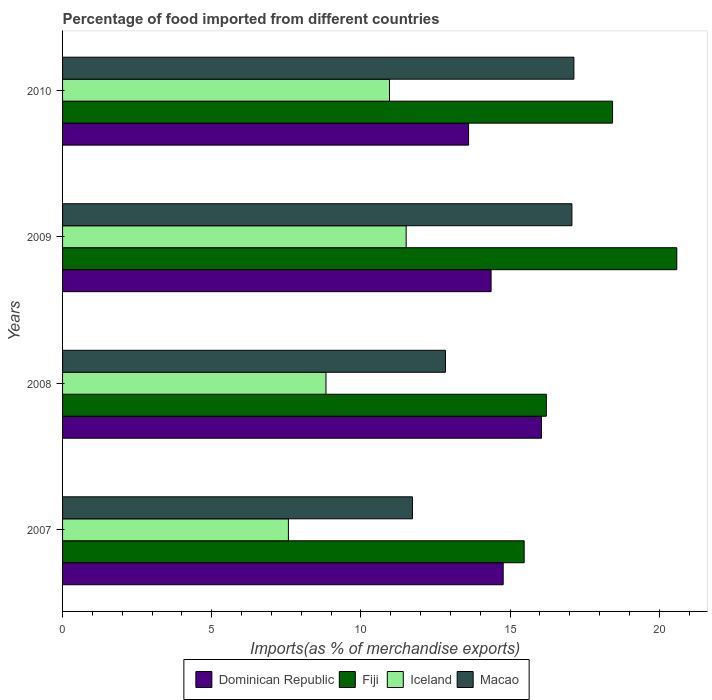Are the number of bars per tick equal to the number of legend labels?
Provide a short and direct response. Yes. Are the number of bars on each tick of the Y-axis equal?
Provide a succinct answer. Yes. How many bars are there on the 1st tick from the bottom?
Keep it short and to the point. 4. What is the label of the 3rd group of bars from the top?
Your answer should be compact. 2008. In how many cases, is the number of bars for a given year not equal to the number of legend labels?
Ensure brevity in your answer.  0. What is the percentage of imports to different countries in Macao in 2009?
Offer a terse response. 17.07. Across all years, what is the maximum percentage of imports to different countries in Fiji?
Offer a terse response. 20.59. Across all years, what is the minimum percentage of imports to different countries in Dominican Republic?
Offer a very short reply. 13.61. In which year was the percentage of imports to different countries in Dominican Republic minimum?
Keep it short and to the point. 2010. What is the total percentage of imports to different countries in Macao in the graph?
Keep it short and to the point. 58.77. What is the difference between the percentage of imports to different countries in Dominican Republic in 2009 and that in 2010?
Give a very brief answer. 0.75. What is the difference between the percentage of imports to different countries in Fiji in 2010 and the percentage of imports to different countries in Dominican Republic in 2009?
Offer a very short reply. 4.07. What is the average percentage of imports to different countries in Dominican Republic per year?
Your answer should be very brief. 14.7. In the year 2008, what is the difference between the percentage of imports to different countries in Iceland and percentage of imports to different countries in Dominican Republic?
Offer a very short reply. -7.22. What is the ratio of the percentage of imports to different countries in Macao in 2008 to that in 2009?
Your response must be concise. 0.75. Is the difference between the percentage of imports to different countries in Iceland in 2007 and 2008 greater than the difference between the percentage of imports to different countries in Dominican Republic in 2007 and 2008?
Provide a short and direct response. Yes. What is the difference between the highest and the second highest percentage of imports to different countries in Macao?
Give a very brief answer. 0.07. What is the difference between the highest and the lowest percentage of imports to different countries in Macao?
Your answer should be compact. 5.41. In how many years, is the percentage of imports to different countries in Macao greater than the average percentage of imports to different countries in Macao taken over all years?
Keep it short and to the point. 2. Is the sum of the percentage of imports to different countries in Dominican Republic in 2007 and 2008 greater than the maximum percentage of imports to different countries in Iceland across all years?
Make the answer very short. Yes. Is it the case that in every year, the sum of the percentage of imports to different countries in Macao and percentage of imports to different countries in Fiji is greater than the sum of percentage of imports to different countries in Dominican Republic and percentage of imports to different countries in Iceland?
Offer a very short reply. No. What does the 3rd bar from the top in 2010 represents?
Make the answer very short. Fiji. What does the 1st bar from the bottom in 2009 represents?
Your answer should be compact. Dominican Republic. Is it the case that in every year, the sum of the percentage of imports to different countries in Macao and percentage of imports to different countries in Fiji is greater than the percentage of imports to different countries in Dominican Republic?
Make the answer very short. Yes. How many bars are there?
Make the answer very short. 16. Are all the bars in the graph horizontal?
Give a very brief answer. Yes. How many years are there in the graph?
Your answer should be very brief. 4. What is the difference between two consecutive major ticks on the X-axis?
Give a very brief answer. 5. Are the values on the major ticks of X-axis written in scientific E-notation?
Your answer should be very brief. No. Does the graph contain grids?
Offer a terse response. No. Where does the legend appear in the graph?
Ensure brevity in your answer.  Bottom center. How are the legend labels stacked?
Provide a short and direct response. Horizontal. What is the title of the graph?
Your answer should be very brief. Percentage of food imported from different countries. What is the label or title of the X-axis?
Your response must be concise. Imports(as % of merchandise exports). What is the Imports(as % of merchandise exports) in Dominican Republic in 2007?
Provide a succinct answer. 14.77. What is the Imports(as % of merchandise exports) of Fiji in 2007?
Your answer should be very brief. 15.47. What is the Imports(as % of merchandise exports) of Iceland in 2007?
Offer a terse response. 7.57. What is the Imports(as % of merchandise exports) of Macao in 2007?
Your response must be concise. 11.73. What is the Imports(as % of merchandise exports) of Dominican Republic in 2008?
Offer a terse response. 16.05. What is the Imports(as % of merchandise exports) in Fiji in 2008?
Keep it short and to the point. 16.22. What is the Imports(as % of merchandise exports) of Iceland in 2008?
Your answer should be compact. 8.83. What is the Imports(as % of merchandise exports) in Macao in 2008?
Offer a very short reply. 12.83. What is the Imports(as % of merchandise exports) of Dominican Republic in 2009?
Your response must be concise. 14.36. What is the Imports(as % of merchandise exports) of Fiji in 2009?
Make the answer very short. 20.59. What is the Imports(as % of merchandise exports) of Iceland in 2009?
Give a very brief answer. 11.52. What is the Imports(as % of merchandise exports) in Macao in 2009?
Provide a succinct answer. 17.07. What is the Imports(as % of merchandise exports) of Dominican Republic in 2010?
Offer a very short reply. 13.61. What is the Imports(as % of merchandise exports) in Fiji in 2010?
Provide a succinct answer. 18.43. What is the Imports(as % of merchandise exports) in Iceland in 2010?
Offer a very short reply. 10.96. What is the Imports(as % of merchandise exports) in Macao in 2010?
Make the answer very short. 17.14. Across all years, what is the maximum Imports(as % of merchandise exports) in Dominican Republic?
Your response must be concise. 16.05. Across all years, what is the maximum Imports(as % of merchandise exports) in Fiji?
Keep it short and to the point. 20.59. Across all years, what is the maximum Imports(as % of merchandise exports) in Iceland?
Your answer should be very brief. 11.52. Across all years, what is the maximum Imports(as % of merchandise exports) of Macao?
Ensure brevity in your answer.  17.14. Across all years, what is the minimum Imports(as % of merchandise exports) in Dominican Republic?
Your answer should be very brief. 13.61. Across all years, what is the minimum Imports(as % of merchandise exports) of Fiji?
Provide a short and direct response. 15.47. Across all years, what is the minimum Imports(as % of merchandise exports) of Iceland?
Offer a terse response. 7.57. Across all years, what is the minimum Imports(as % of merchandise exports) of Macao?
Ensure brevity in your answer.  11.73. What is the total Imports(as % of merchandise exports) of Dominican Republic in the graph?
Provide a succinct answer. 58.8. What is the total Imports(as % of merchandise exports) of Fiji in the graph?
Ensure brevity in your answer.  70.71. What is the total Imports(as % of merchandise exports) in Iceland in the graph?
Provide a succinct answer. 38.88. What is the total Imports(as % of merchandise exports) of Macao in the graph?
Give a very brief answer. 58.77. What is the difference between the Imports(as % of merchandise exports) of Dominican Republic in 2007 and that in 2008?
Provide a succinct answer. -1.28. What is the difference between the Imports(as % of merchandise exports) of Fiji in 2007 and that in 2008?
Keep it short and to the point. -0.74. What is the difference between the Imports(as % of merchandise exports) in Iceland in 2007 and that in 2008?
Make the answer very short. -1.26. What is the difference between the Imports(as % of merchandise exports) of Macao in 2007 and that in 2008?
Offer a very short reply. -1.11. What is the difference between the Imports(as % of merchandise exports) in Dominican Republic in 2007 and that in 2009?
Your answer should be compact. 0.41. What is the difference between the Imports(as % of merchandise exports) of Fiji in 2007 and that in 2009?
Offer a terse response. -5.12. What is the difference between the Imports(as % of merchandise exports) of Iceland in 2007 and that in 2009?
Offer a very short reply. -3.95. What is the difference between the Imports(as % of merchandise exports) of Macao in 2007 and that in 2009?
Offer a terse response. -5.35. What is the difference between the Imports(as % of merchandise exports) of Dominican Republic in 2007 and that in 2010?
Your response must be concise. 1.16. What is the difference between the Imports(as % of merchandise exports) of Fiji in 2007 and that in 2010?
Keep it short and to the point. -2.96. What is the difference between the Imports(as % of merchandise exports) of Iceland in 2007 and that in 2010?
Keep it short and to the point. -3.39. What is the difference between the Imports(as % of merchandise exports) of Macao in 2007 and that in 2010?
Your answer should be compact. -5.41. What is the difference between the Imports(as % of merchandise exports) in Dominican Republic in 2008 and that in 2009?
Your answer should be compact. 1.69. What is the difference between the Imports(as % of merchandise exports) in Fiji in 2008 and that in 2009?
Your answer should be compact. -4.37. What is the difference between the Imports(as % of merchandise exports) in Iceland in 2008 and that in 2009?
Keep it short and to the point. -2.69. What is the difference between the Imports(as % of merchandise exports) in Macao in 2008 and that in 2009?
Your response must be concise. -4.24. What is the difference between the Imports(as % of merchandise exports) of Dominican Republic in 2008 and that in 2010?
Your response must be concise. 2.44. What is the difference between the Imports(as % of merchandise exports) in Fiji in 2008 and that in 2010?
Your response must be concise. -2.22. What is the difference between the Imports(as % of merchandise exports) of Iceland in 2008 and that in 2010?
Ensure brevity in your answer.  -2.13. What is the difference between the Imports(as % of merchandise exports) in Macao in 2008 and that in 2010?
Make the answer very short. -4.31. What is the difference between the Imports(as % of merchandise exports) of Dominican Republic in 2009 and that in 2010?
Ensure brevity in your answer.  0.75. What is the difference between the Imports(as % of merchandise exports) in Fiji in 2009 and that in 2010?
Provide a succinct answer. 2.15. What is the difference between the Imports(as % of merchandise exports) in Iceland in 2009 and that in 2010?
Make the answer very short. 0.56. What is the difference between the Imports(as % of merchandise exports) in Macao in 2009 and that in 2010?
Ensure brevity in your answer.  -0.07. What is the difference between the Imports(as % of merchandise exports) of Dominican Republic in 2007 and the Imports(as % of merchandise exports) of Fiji in 2008?
Offer a terse response. -1.45. What is the difference between the Imports(as % of merchandise exports) of Dominican Republic in 2007 and the Imports(as % of merchandise exports) of Iceland in 2008?
Your answer should be very brief. 5.94. What is the difference between the Imports(as % of merchandise exports) of Dominican Republic in 2007 and the Imports(as % of merchandise exports) of Macao in 2008?
Give a very brief answer. 1.94. What is the difference between the Imports(as % of merchandise exports) in Fiji in 2007 and the Imports(as % of merchandise exports) in Iceland in 2008?
Provide a succinct answer. 6.64. What is the difference between the Imports(as % of merchandise exports) in Fiji in 2007 and the Imports(as % of merchandise exports) in Macao in 2008?
Offer a very short reply. 2.64. What is the difference between the Imports(as % of merchandise exports) of Iceland in 2007 and the Imports(as % of merchandise exports) of Macao in 2008?
Your answer should be compact. -5.26. What is the difference between the Imports(as % of merchandise exports) of Dominican Republic in 2007 and the Imports(as % of merchandise exports) of Fiji in 2009?
Provide a short and direct response. -5.82. What is the difference between the Imports(as % of merchandise exports) in Dominican Republic in 2007 and the Imports(as % of merchandise exports) in Iceland in 2009?
Keep it short and to the point. 3.25. What is the difference between the Imports(as % of merchandise exports) of Dominican Republic in 2007 and the Imports(as % of merchandise exports) of Macao in 2009?
Your answer should be very brief. -2.3. What is the difference between the Imports(as % of merchandise exports) in Fiji in 2007 and the Imports(as % of merchandise exports) in Iceland in 2009?
Offer a very short reply. 3.96. What is the difference between the Imports(as % of merchandise exports) of Fiji in 2007 and the Imports(as % of merchandise exports) of Macao in 2009?
Provide a succinct answer. -1.6. What is the difference between the Imports(as % of merchandise exports) in Iceland in 2007 and the Imports(as % of merchandise exports) in Macao in 2009?
Keep it short and to the point. -9.5. What is the difference between the Imports(as % of merchandise exports) in Dominican Republic in 2007 and the Imports(as % of merchandise exports) in Fiji in 2010?
Give a very brief answer. -3.67. What is the difference between the Imports(as % of merchandise exports) in Dominican Republic in 2007 and the Imports(as % of merchandise exports) in Iceland in 2010?
Ensure brevity in your answer.  3.81. What is the difference between the Imports(as % of merchandise exports) of Dominican Republic in 2007 and the Imports(as % of merchandise exports) of Macao in 2010?
Your response must be concise. -2.37. What is the difference between the Imports(as % of merchandise exports) in Fiji in 2007 and the Imports(as % of merchandise exports) in Iceland in 2010?
Make the answer very short. 4.51. What is the difference between the Imports(as % of merchandise exports) in Fiji in 2007 and the Imports(as % of merchandise exports) in Macao in 2010?
Your response must be concise. -1.67. What is the difference between the Imports(as % of merchandise exports) in Iceland in 2007 and the Imports(as % of merchandise exports) in Macao in 2010?
Offer a very short reply. -9.57. What is the difference between the Imports(as % of merchandise exports) of Dominican Republic in 2008 and the Imports(as % of merchandise exports) of Fiji in 2009?
Provide a succinct answer. -4.53. What is the difference between the Imports(as % of merchandise exports) in Dominican Republic in 2008 and the Imports(as % of merchandise exports) in Iceland in 2009?
Your answer should be very brief. 4.54. What is the difference between the Imports(as % of merchandise exports) in Dominican Republic in 2008 and the Imports(as % of merchandise exports) in Macao in 2009?
Provide a short and direct response. -1.02. What is the difference between the Imports(as % of merchandise exports) of Fiji in 2008 and the Imports(as % of merchandise exports) of Iceland in 2009?
Provide a short and direct response. 4.7. What is the difference between the Imports(as % of merchandise exports) of Fiji in 2008 and the Imports(as % of merchandise exports) of Macao in 2009?
Provide a succinct answer. -0.86. What is the difference between the Imports(as % of merchandise exports) in Iceland in 2008 and the Imports(as % of merchandise exports) in Macao in 2009?
Offer a very short reply. -8.24. What is the difference between the Imports(as % of merchandise exports) of Dominican Republic in 2008 and the Imports(as % of merchandise exports) of Fiji in 2010?
Offer a very short reply. -2.38. What is the difference between the Imports(as % of merchandise exports) in Dominican Republic in 2008 and the Imports(as % of merchandise exports) in Iceland in 2010?
Offer a terse response. 5.09. What is the difference between the Imports(as % of merchandise exports) in Dominican Republic in 2008 and the Imports(as % of merchandise exports) in Macao in 2010?
Your response must be concise. -1.09. What is the difference between the Imports(as % of merchandise exports) of Fiji in 2008 and the Imports(as % of merchandise exports) of Iceland in 2010?
Offer a terse response. 5.26. What is the difference between the Imports(as % of merchandise exports) in Fiji in 2008 and the Imports(as % of merchandise exports) in Macao in 2010?
Your answer should be very brief. -0.92. What is the difference between the Imports(as % of merchandise exports) in Iceland in 2008 and the Imports(as % of merchandise exports) in Macao in 2010?
Offer a terse response. -8.31. What is the difference between the Imports(as % of merchandise exports) in Dominican Republic in 2009 and the Imports(as % of merchandise exports) in Fiji in 2010?
Ensure brevity in your answer.  -4.07. What is the difference between the Imports(as % of merchandise exports) in Dominican Republic in 2009 and the Imports(as % of merchandise exports) in Iceland in 2010?
Provide a succinct answer. 3.4. What is the difference between the Imports(as % of merchandise exports) in Dominican Republic in 2009 and the Imports(as % of merchandise exports) in Macao in 2010?
Make the answer very short. -2.78. What is the difference between the Imports(as % of merchandise exports) of Fiji in 2009 and the Imports(as % of merchandise exports) of Iceland in 2010?
Your answer should be compact. 9.63. What is the difference between the Imports(as % of merchandise exports) of Fiji in 2009 and the Imports(as % of merchandise exports) of Macao in 2010?
Provide a succinct answer. 3.45. What is the difference between the Imports(as % of merchandise exports) of Iceland in 2009 and the Imports(as % of merchandise exports) of Macao in 2010?
Offer a terse response. -5.62. What is the average Imports(as % of merchandise exports) of Dominican Republic per year?
Ensure brevity in your answer.  14.7. What is the average Imports(as % of merchandise exports) in Fiji per year?
Provide a short and direct response. 17.68. What is the average Imports(as % of merchandise exports) in Iceland per year?
Your answer should be very brief. 9.72. What is the average Imports(as % of merchandise exports) in Macao per year?
Ensure brevity in your answer.  14.69. In the year 2007, what is the difference between the Imports(as % of merchandise exports) in Dominican Republic and Imports(as % of merchandise exports) in Fiji?
Keep it short and to the point. -0.7. In the year 2007, what is the difference between the Imports(as % of merchandise exports) of Dominican Republic and Imports(as % of merchandise exports) of Iceland?
Your answer should be very brief. 7.2. In the year 2007, what is the difference between the Imports(as % of merchandise exports) in Dominican Republic and Imports(as % of merchandise exports) in Macao?
Make the answer very short. 3.04. In the year 2007, what is the difference between the Imports(as % of merchandise exports) of Fiji and Imports(as % of merchandise exports) of Iceland?
Your answer should be compact. 7.9. In the year 2007, what is the difference between the Imports(as % of merchandise exports) in Fiji and Imports(as % of merchandise exports) in Macao?
Make the answer very short. 3.75. In the year 2007, what is the difference between the Imports(as % of merchandise exports) in Iceland and Imports(as % of merchandise exports) in Macao?
Offer a very short reply. -4.16. In the year 2008, what is the difference between the Imports(as % of merchandise exports) in Dominican Republic and Imports(as % of merchandise exports) in Fiji?
Provide a short and direct response. -0.16. In the year 2008, what is the difference between the Imports(as % of merchandise exports) in Dominican Republic and Imports(as % of merchandise exports) in Iceland?
Keep it short and to the point. 7.22. In the year 2008, what is the difference between the Imports(as % of merchandise exports) of Dominican Republic and Imports(as % of merchandise exports) of Macao?
Ensure brevity in your answer.  3.22. In the year 2008, what is the difference between the Imports(as % of merchandise exports) in Fiji and Imports(as % of merchandise exports) in Iceland?
Provide a short and direct response. 7.39. In the year 2008, what is the difference between the Imports(as % of merchandise exports) in Fiji and Imports(as % of merchandise exports) in Macao?
Provide a succinct answer. 3.38. In the year 2008, what is the difference between the Imports(as % of merchandise exports) in Iceland and Imports(as % of merchandise exports) in Macao?
Provide a succinct answer. -4.01. In the year 2009, what is the difference between the Imports(as % of merchandise exports) of Dominican Republic and Imports(as % of merchandise exports) of Fiji?
Offer a terse response. -6.22. In the year 2009, what is the difference between the Imports(as % of merchandise exports) in Dominican Republic and Imports(as % of merchandise exports) in Iceland?
Give a very brief answer. 2.85. In the year 2009, what is the difference between the Imports(as % of merchandise exports) in Dominican Republic and Imports(as % of merchandise exports) in Macao?
Provide a short and direct response. -2.71. In the year 2009, what is the difference between the Imports(as % of merchandise exports) of Fiji and Imports(as % of merchandise exports) of Iceland?
Ensure brevity in your answer.  9.07. In the year 2009, what is the difference between the Imports(as % of merchandise exports) of Fiji and Imports(as % of merchandise exports) of Macao?
Offer a very short reply. 3.52. In the year 2009, what is the difference between the Imports(as % of merchandise exports) of Iceland and Imports(as % of merchandise exports) of Macao?
Offer a very short reply. -5.56. In the year 2010, what is the difference between the Imports(as % of merchandise exports) of Dominican Republic and Imports(as % of merchandise exports) of Fiji?
Make the answer very short. -4.83. In the year 2010, what is the difference between the Imports(as % of merchandise exports) of Dominican Republic and Imports(as % of merchandise exports) of Iceland?
Offer a terse response. 2.65. In the year 2010, what is the difference between the Imports(as % of merchandise exports) of Dominican Republic and Imports(as % of merchandise exports) of Macao?
Your answer should be compact. -3.53. In the year 2010, what is the difference between the Imports(as % of merchandise exports) in Fiji and Imports(as % of merchandise exports) in Iceland?
Your response must be concise. 7.48. In the year 2010, what is the difference between the Imports(as % of merchandise exports) of Fiji and Imports(as % of merchandise exports) of Macao?
Your answer should be compact. 1.3. In the year 2010, what is the difference between the Imports(as % of merchandise exports) of Iceland and Imports(as % of merchandise exports) of Macao?
Offer a terse response. -6.18. What is the ratio of the Imports(as % of merchandise exports) of Fiji in 2007 to that in 2008?
Provide a short and direct response. 0.95. What is the ratio of the Imports(as % of merchandise exports) of Iceland in 2007 to that in 2008?
Your answer should be very brief. 0.86. What is the ratio of the Imports(as % of merchandise exports) of Macao in 2007 to that in 2008?
Keep it short and to the point. 0.91. What is the ratio of the Imports(as % of merchandise exports) of Dominican Republic in 2007 to that in 2009?
Keep it short and to the point. 1.03. What is the ratio of the Imports(as % of merchandise exports) in Fiji in 2007 to that in 2009?
Your answer should be compact. 0.75. What is the ratio of the Imports(as % of merchandise exports) in Iceland in 2007 to that in 2009?
Your answer should be compact. 0.66. What is the ratio of the Imports(as % of merchandise exports) in Macao in 2007 to that in 2009?
Your response must be concise. 0.69. What is the ratio of the Imports(as % of merchandise exports) in Dominican Republic in 2007 to that in 2010?
Provide a succinct answer. 1.09. What is the ratio of the Imports(as % of merchandise exports) in Fiji in 2007 to that in 2010?
Offer a terse response. 0.84. What is the ratio of the Imports(as % of merchandise exports) in Iceland in 2007 to that in 2010?
Offer a terse response. 0.69. What is the ratio of the Imports(as % of merchandise exports) in Macao in 2007 to that in 2010?
Your answer should be compact. 0.68. What is the ratio of the Imports(as % of merchandise exports) in Dominican Republic in 2008 to that in 2009?
Provide a short and direct response. 1.12. What is the ratio of the Imports(as % of merchandise exports) in Fiji in 2008 to that in 2009?
Your answer should be compact. 0.79. What is the ratio of the Imports(as % of merchandise exports) in Iceland in 2008 to that in 2009?
Offer a very short reply. 0.77. What is the ratio of the Imports(as % of merchandise exports) of Macao in 2008 to that in 2009?
Provide a succinct answer. 0.75. What is the ratio of the Imports(as % of merchandise exports) of Dominican Republic in 2008 to that in 2010?
Your response must be concise. 1.18. What is the ratio of the Imports(as % of merchandise exports) of Fiji in 2008 to that in 2010?
Make the answer very short. 0.88. What is the ratio of the Imports(as % of merchandise exports) of Iceland in 2008 to that in 2010?
Provide a succinct answer. 0.81. What is the ratio of the Imports(as % of merchandise exports) of Macao in 2008 to that in 2010?
Your answer should be compact. 0.75. What is the ratio of the Imports(as % of merchandise exports) of Dominican Republic in 2009 to that in 2010?
Keep it short and to the point. 1.06. What is the ratio of the Imports(as % of merchandise exports) in Fiji in 2009 to that in 2010?
Your response must be concise. 1.12. What is the ratio of the Imports(as % of merchandise exports) of Iceland in 2009 to that in 2010?
Your answer should be compact. 1.05. What is the ratio of the Imports(as % of merchandise exports) of Macao in 2009 to that in 2010?
Your answer should be compact. 1. What is the difference between the highest and the second highest Imports(as % of merchandise exports) in Dominican Republic?
Make the answer very short. 1.28. What is the difference between the highest and the second highest Imports(as % of merchandise exports) in Fiji?
Offer a very short reply. 2.15. What is the difference between the highest and the second highest Imports(as % of merchandise exports) in Iceland?
Make the answer very short. 0.56. What is the difference between the highest and the second highest Imports(as % of merchandise exports) in Macao?
Your answer should be compact. 0.07. What is the difference between the highest and the lowest Imports(as % of merchandise exports) of Dominican Republic?
Offer a very short reply. 2.44. What is the difference between the highest and the lowest Imports(as % of merchandise exports) of Fiji?
Your response must be concise. 5.12. What is the difference between the highest and the lowest Imports(as % of merchandise exports) of Iceland?
Offer a terse response. 3.95. What is the difference between the highest and the lowest Imports(as % of merchandise exports) of Macao?
Your response must be concise. 5.41. 